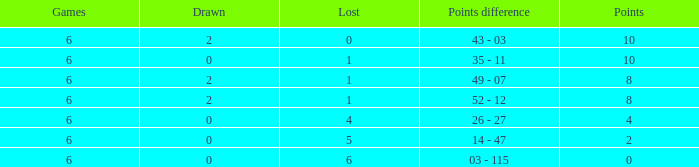What was the highest points where there were less than 2 drawn and the games were less than 6? None. 